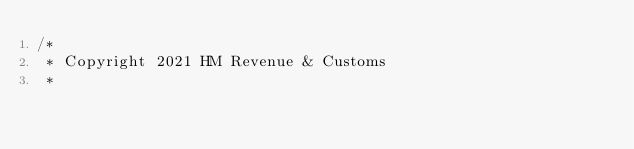Convert code to text. <code><loc_0><loc_0><loc_500><loc_500><_Scala_>/*
 * Copyright 2021 HM Revenue & Customs
 *</code> 